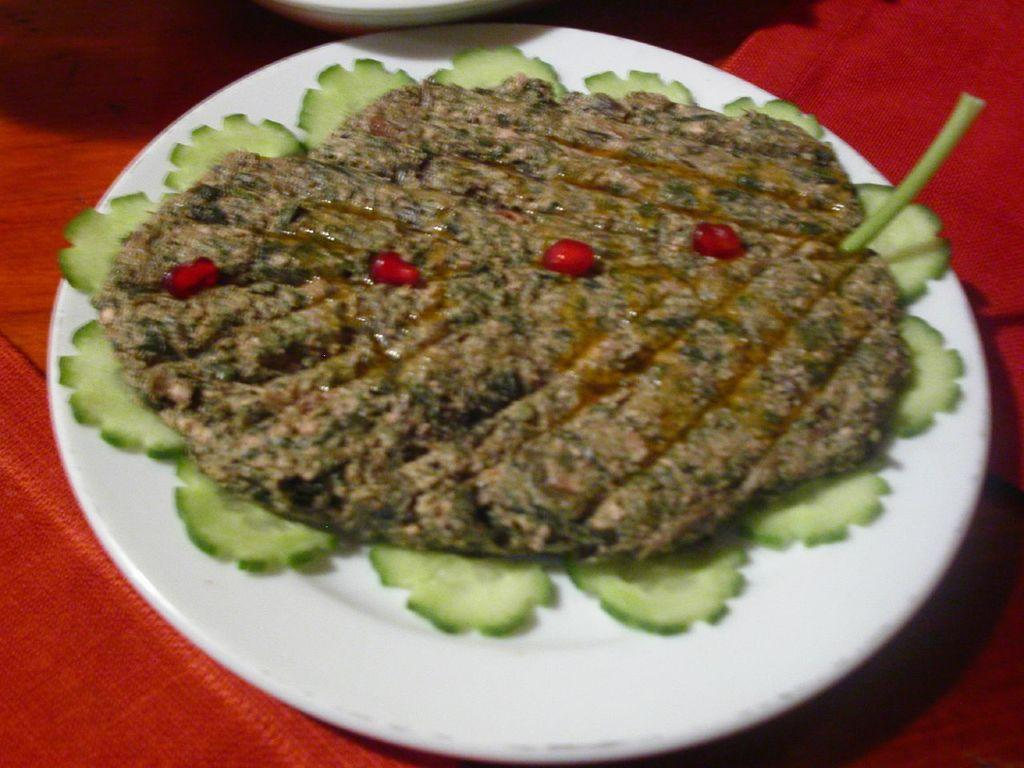What is on the plate that is visible in the image? There is food on a plate in the image. Where is the plate located in the image? The plate is in the center of the image. What memory does the banana have of the writer in the image? There is no banana or writer present in the image, so it is not possible to answer that question. 